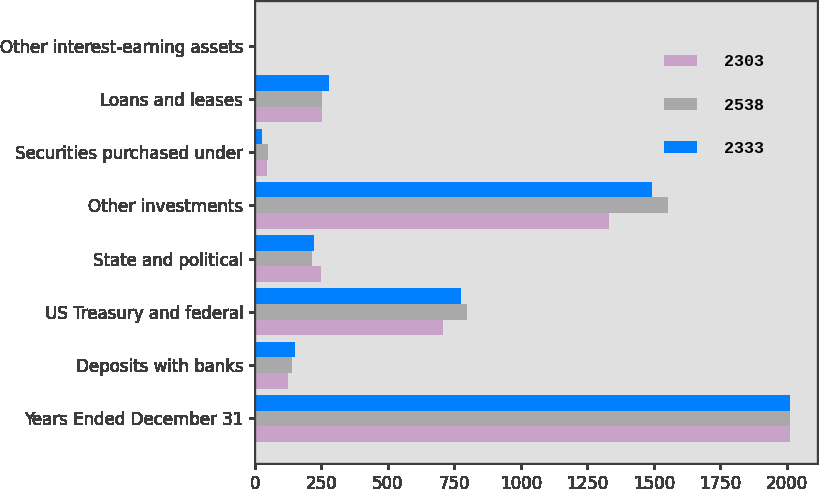Convert chart to OTSL. <chart><loc_0><loc_0><loc_500><loc_500><stacked_bar_chart><ecel><fcel>Years Ended December 31<fcel>Deposits with banks<fcel>US Treasury and federal<fcel>State and political<fcel>Other investments<fcel>Securities purchased under<fcel>Loans and leases<fcel>Other interest-earning assets<nl><fcel>2303<fcel>2013<fcel>125<fcel>706<fcel>250<fcel>1332<fcel>45<fcel>252<fcel>4<nl><fcel>2538<fcel>2012<fcel>141<fcel>799<fcel>215<fcel>1552<fcel>51<fcel>253<fcel>3<nl><fcel>2333<fcel>2011<fcel>149<fcel>775<fcel>221<fcel>1493<fcel>28<fcel>278<fcel>2<nl></chart> 